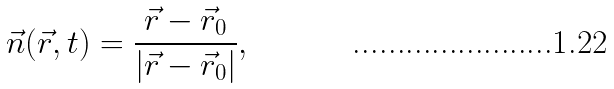Convert formula to latex. <formula><loc_0><loc_0><loc_500><loc_500>\vec { n } ( \vec { r } , t ) = \frac { \vec { r } - \vec { r } _ { 0 } } { | \vec { r } - \vec { r } _ { 0 } | } ,</formula> 